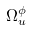Convert formula to latex. <formula><loc_0><loc_0><loc_500><loc_500>\Omega _ { u } ^ { \phi }</formula> 